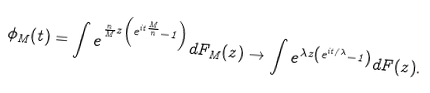<formula> <loc_0><loc_0><loc_500><loc_500>\phi _ { M } ( t ) = \int e ^ { \frac { n } { M } z \left ( e ^ { i t \frac { M } { n } } - 1 \right ) } d F _ { M } ( z ) \to \int e ^ { \lambda z \left ( e ^ { i t / \lambda } - 1 \right ) } d F ( z ) .</formula> 